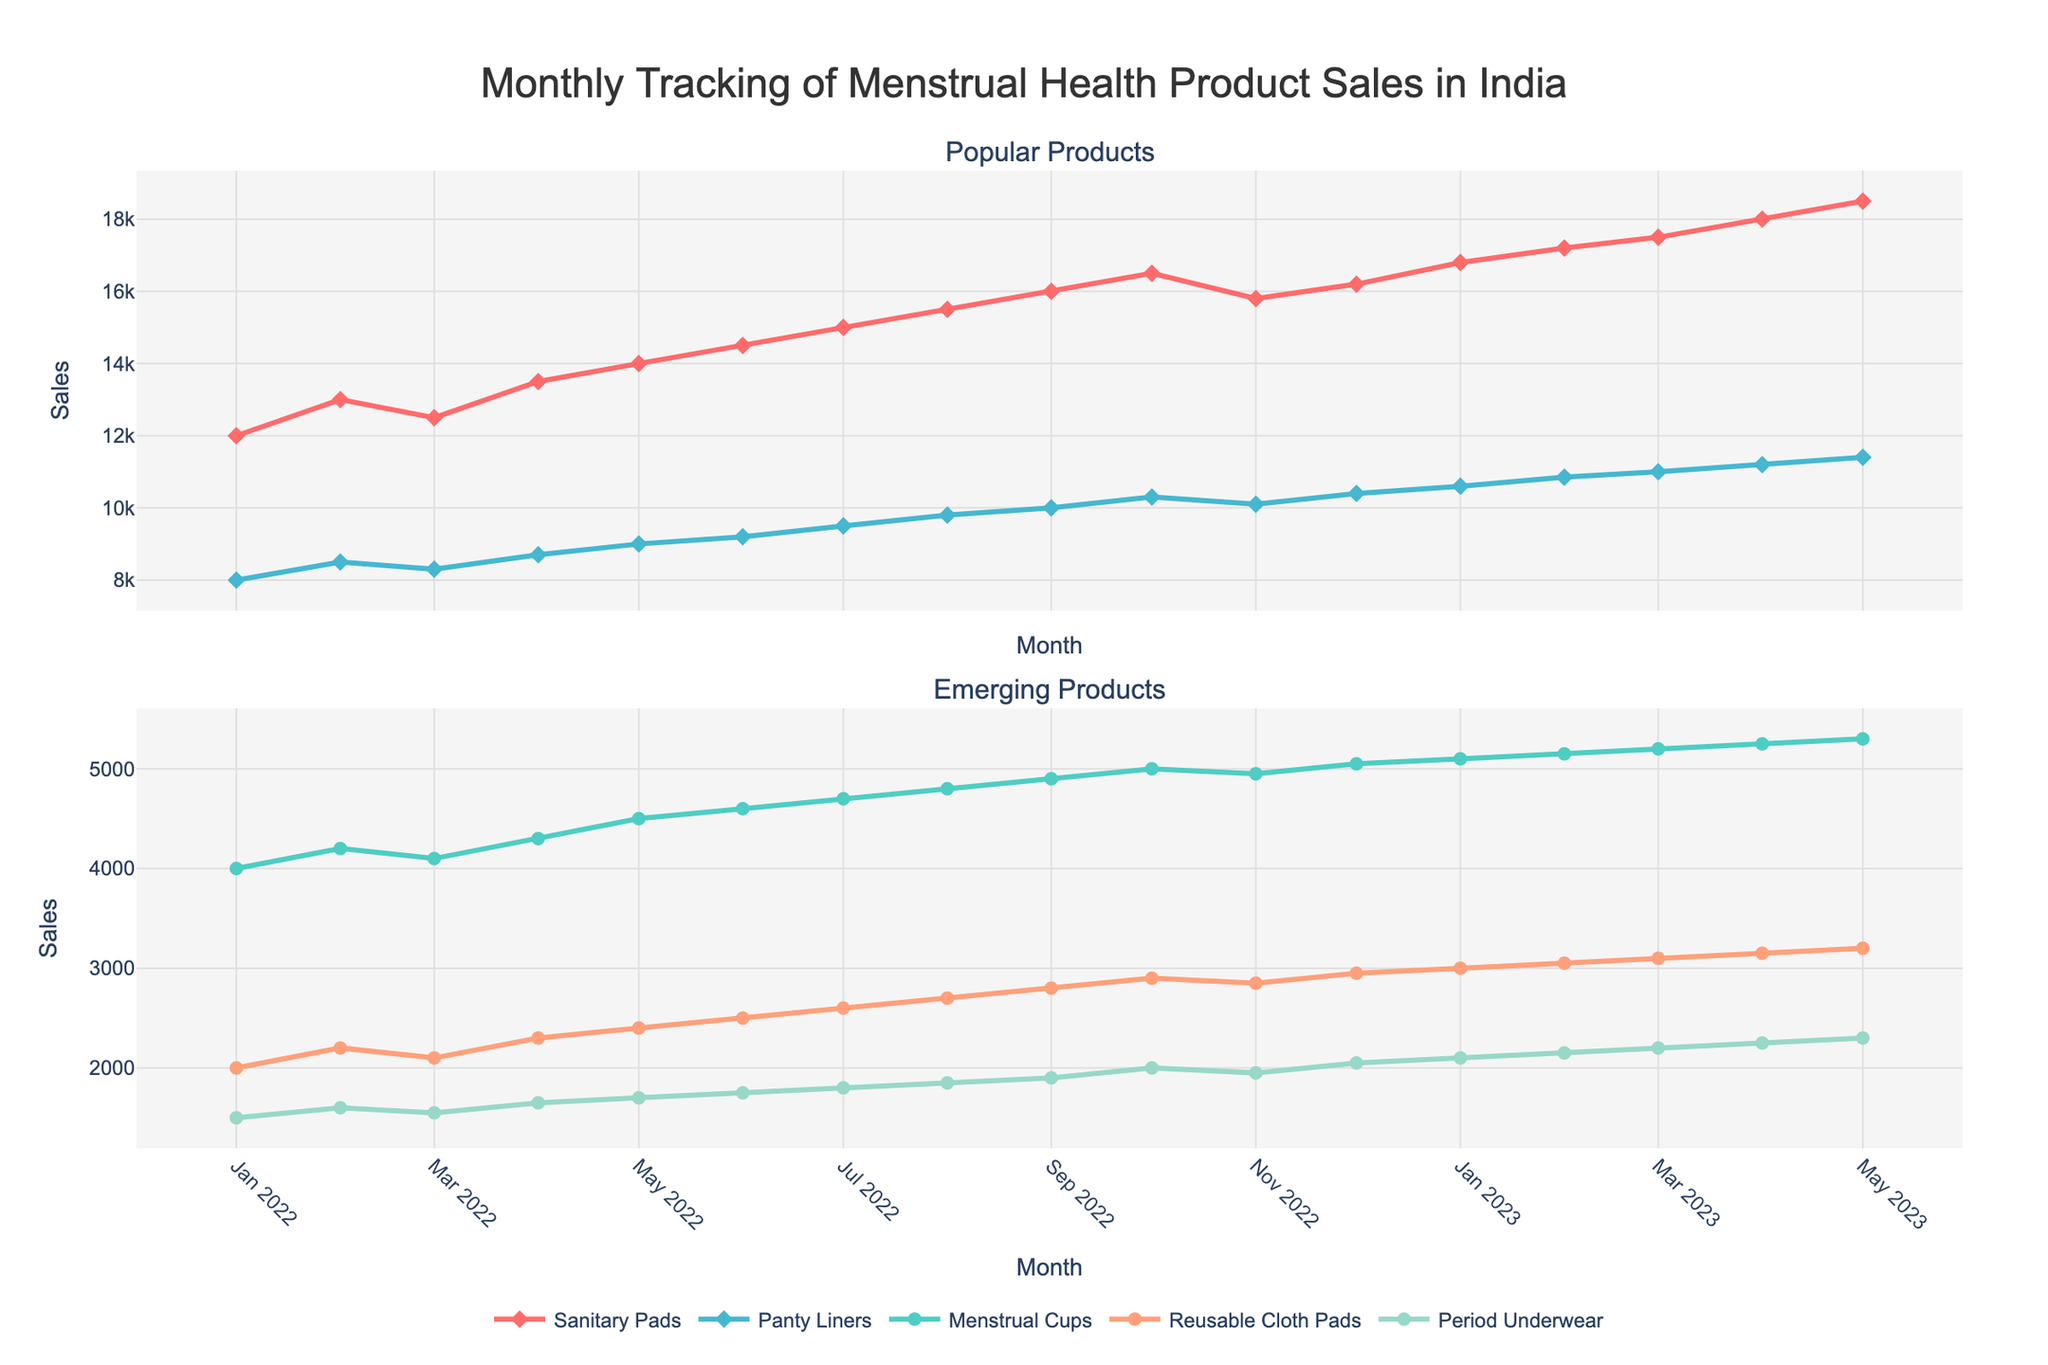What is the title of the figure? The title is usually prominently displayed at the top of the plot. Here, it reads "Monthly Tracking of Menstrual Health Product Sales in India".
Answer: Monthly Tracking of Menstrual Health Product Sales in India How many subplots are there in the figure? The figure is divided into two main sections, or subplots, separated horizontally.
Answer: 2 What are the popular menstrual health products shown in the figure? In the first subplot, the popular products are mentioned in the legend. They are "Sanitary Pads" and "Panty Liners".
Answer: Sanitary Pads and Panty Liners Which product saw the highest sales in May 2023? Examine the y-values corresponding to May 2023 for each product. The highest value is for "Sanitary Pads", reaching 18,500 sales.
Answer: Sanitary Pads How did the sales of Menstrual Cups change from January 2022 to May 2023? Look at the y-values for "Menstrual Cups" in January 2022 (4,000) and in May 2023 (5,300). The sales increased by (5,300 - 4,000) = 1,300.
Answer: Increased by 1,300 Which product had the least sales in January 2022? Check the y-values of all products for January 2022. "Period Underwear" had the lowest sales, with 1,500.
Answer: Period Underwear Between which months did the sales of Panty Liners see the most significant increase? Analyze the y-values for "Panty Liners" across each month. The largest increase happened between December 2022 (10,400) and January 2023 (10,600) with an increase of 200.
Answer: December 2022 and January 2023 Did the sales of Reusable Cloth Pads consistently increase over the time period? Follow the trend line for "Reusable Cloth Pads" across the plot. Each month's sales are higher than the previous month's, indicating a consistent increase.
Answer: Yes In which month did Period Underwear sales first surpass 2,000? Look at the y-values for "Period Underwear". They first surpassed 2,000 in October 2022.
Answer: October 2022 What is the difference in sales between Sanitary Pads and Menstrual Cups in February 2023? Compare the sales values for these two products in February 2023. Sanitary Pads had 17,200 sales, and Menstrual Cups had 5,150 sales. The difference is (17,200 - 5,150) = 12,050.
Answer: 12,050 